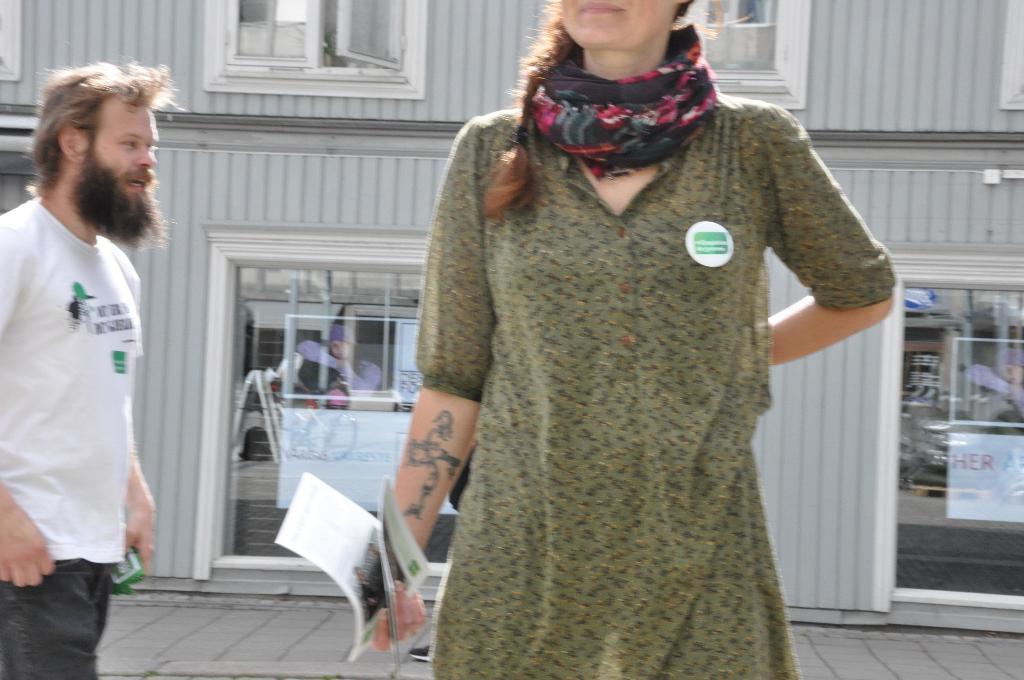Can you describe this image briefly? This picture is clicked outside. In the foreground there is a woman holding some objects and seems to be standing. On the left there is a man wearing white color t-shirt and seems to be walking on the ground. In the background we can see the windows and the doors of a building. 